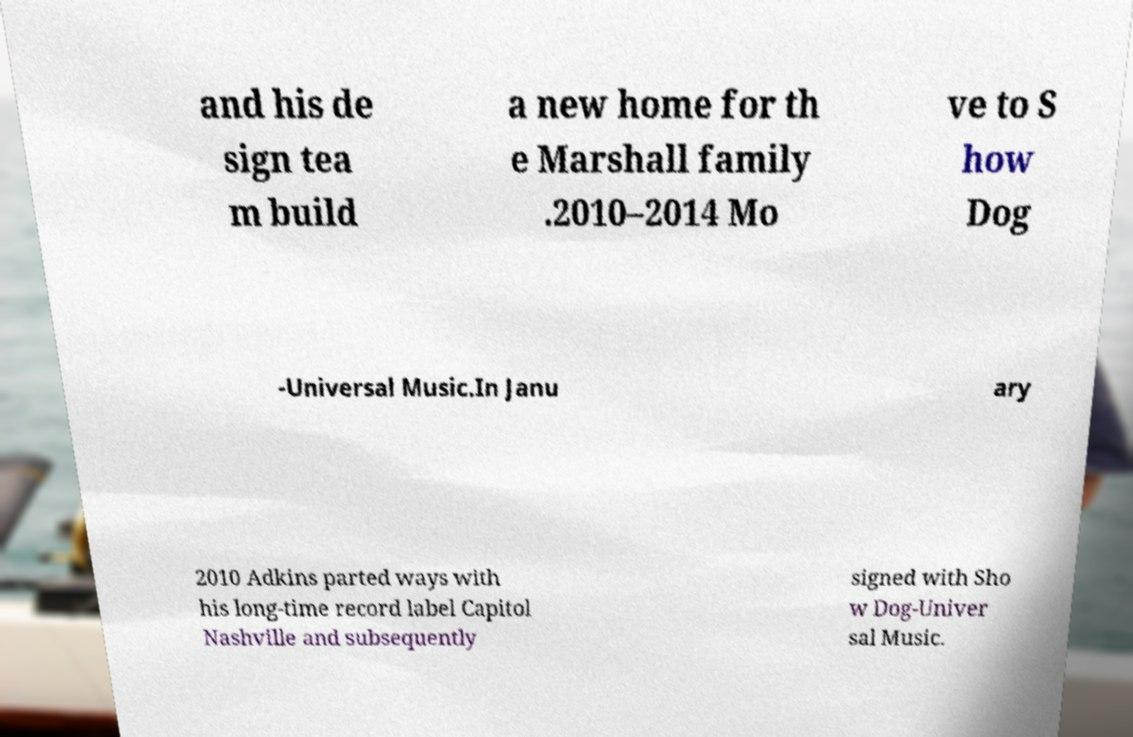I need the written content from this picture converted into text. Can you do that? and his de sign tea m build a new home for th e Marshall family .2010–2014 Mo ve to S how Dog -Universal Music.In Janu ary 2010 Adkins parted ways with his long-time record label Capitol Nashville and subsequently signed with Sho w Dog-Univer sal Music. 